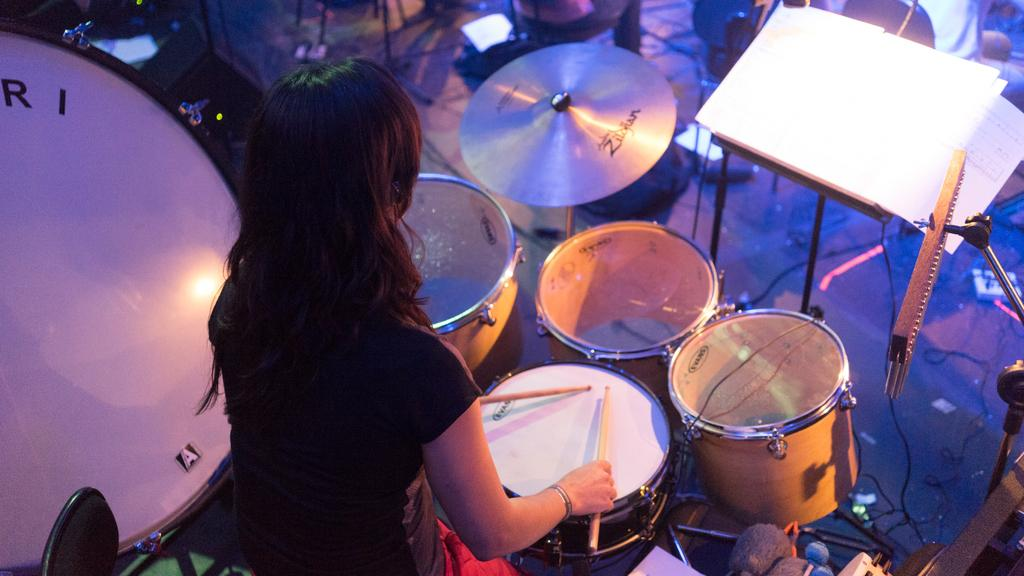Who is present in the image? There is a woman in the image. What is the woman holding in her hand? The woman is holding sticks in her hand. What objects related to music can be seen in the image? There are drums in the image. What non-musical object is present in the image? There is a book in the image. What direction is the woman facing in the image? The provided facts do not mention the direction the woman is facing, so it cannot be determined from the image. 